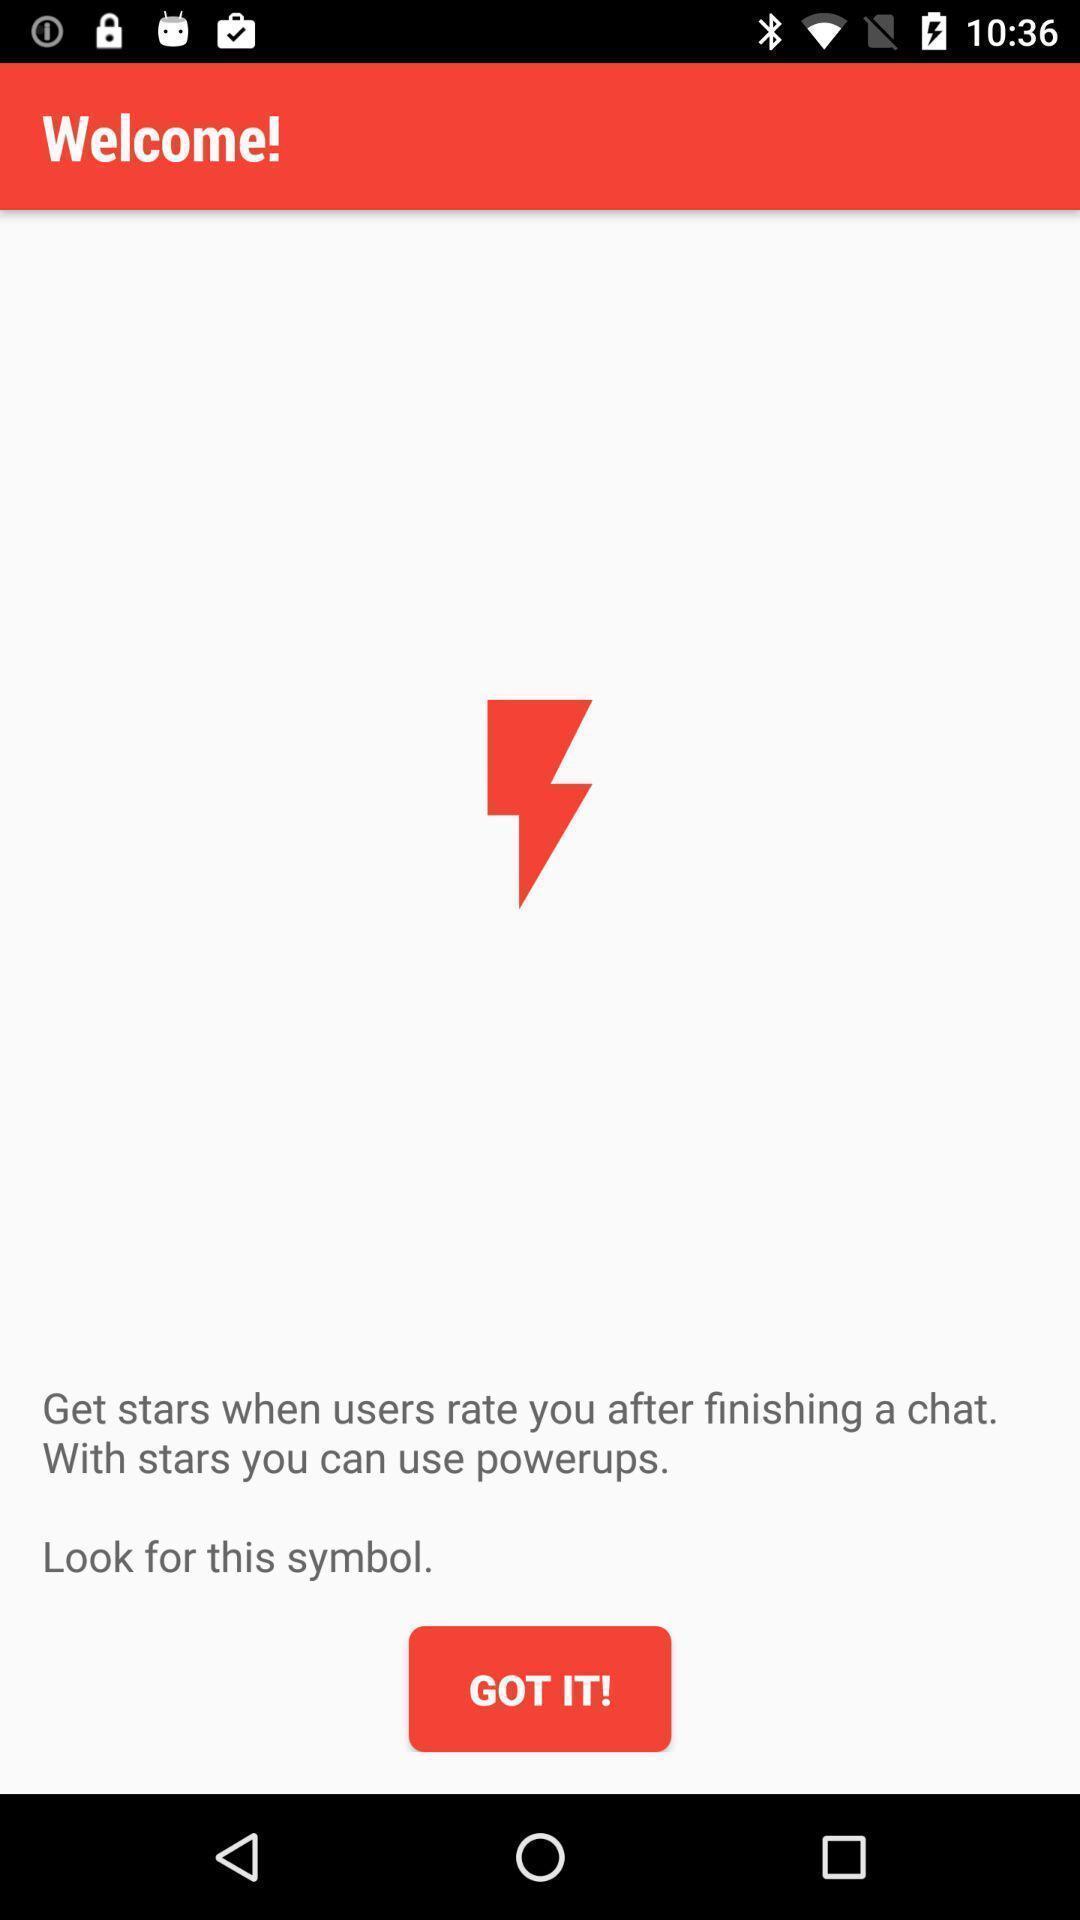Explain the elements present in this screenshot. Welcome page. 